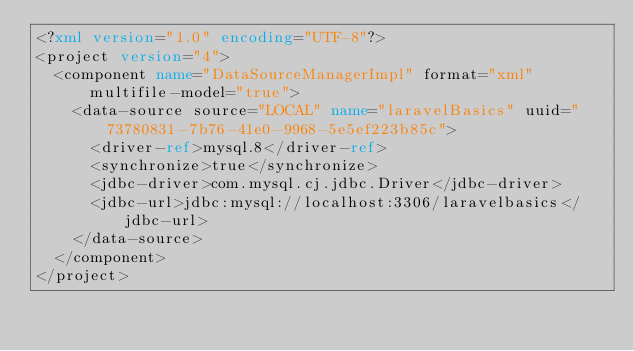<code> <loc_0><loc_0><loc_500><loc_500><_XML_><?xml version="1.0" encoding="UTF-8"?>
<project version="4">
  <component name="DataSourceManagerImpl" format="xml" multifile-model="true">
    <data-source source="LOCAL" name="laravelBasics" uuid="73780831-7b76-41e0-9968-5e5ef223b85c">
      <driver-ref>mysql.8</driver-ref>
      <synchronize>true</synchronize>
      <jdbc-driver>com.mysql.cj.jdbc.Driver</jdbc-driver>
      <jdbc-url>jdbc:mysql://localhost:3306/laravelbasics</jdbc-url>
    </data-source>
  </component>
</project></code> 